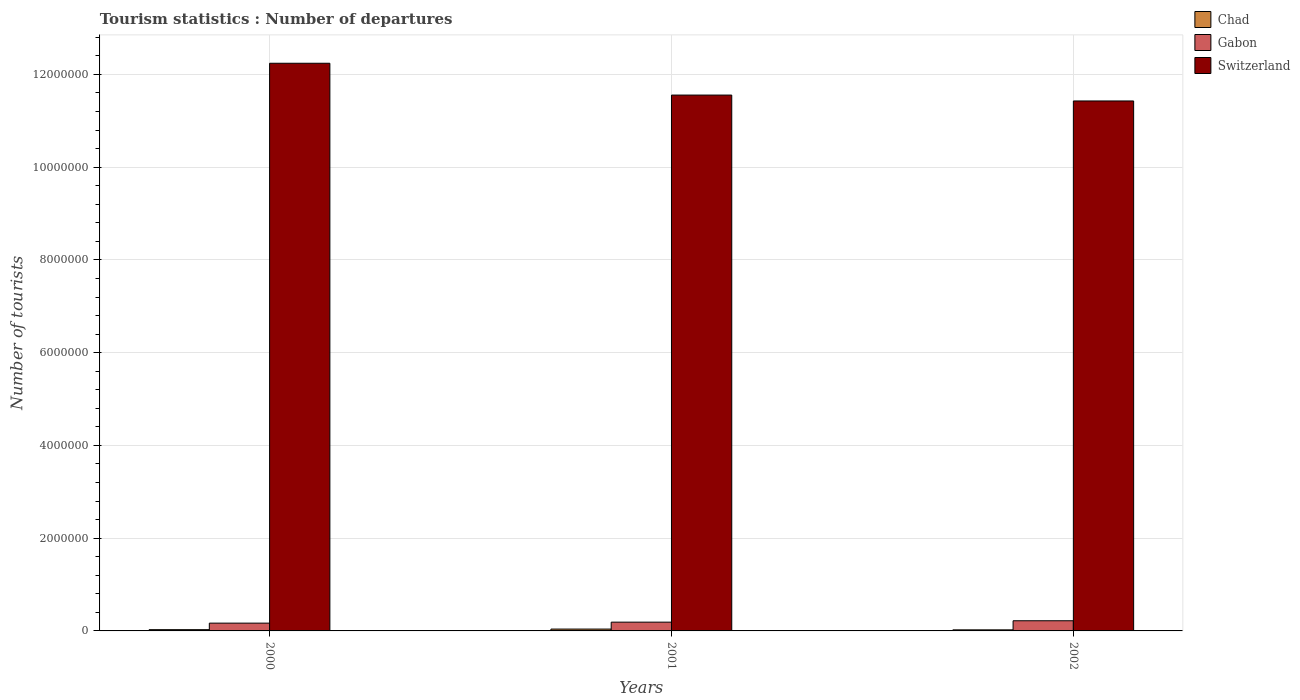How many different coloured bars are there?
Provide a succinct answer. 3. How many groups of bars are there?
Ensure brevity in your answer.  3. Are the number of bars on each tick of the X-axis equal?
Your answer should be very brief. Yes. How many bars are there on the 1st tick from the right?
Keep it short and to the point. 3. What is the label of the 3rd group of bars from the left?
Keep it short and to the point. 2002. In how many cases, is the number of bars for a given year not equal to the number of legend labels?
Your answer should be very brief. 0. What is the number of tourist departures in Gabon in 2002?
Provide a succinct answer. 2.19e+05. Across all years, what is the maximum number of tourist departures in Chad?
Your answer should be very brief. 4.00e+04. Across all years, what is the minimum number of tourist departures in Switzerland?
Your answer should be compact. 1.14e+07. In which year was the number of tourist departures in Switzerland minimum?
Your answer should be compact. 2002. What is the total number of tourist departures in Switzerland in the graph?
Your answer should be very brief. 3.52e+07. What is the difference between the number of tourist departures in Gabon in 2000 and that in 2002?
Offer a terse response. -5.10e+04. What is the difference between the number of tourist departures in Gabon in 2000 and the number of tourist departures in Chad in 2002?
Provide a succinct answer. 1.45e+05. What is the average number of tourist departures in Switzerland per year?
Give a very brief answer. 1.17e+07. In the year 2000, what is the difference between the number of tourist departures in Switzerland and number of tourist departures in Chad?
Make the answer very short. 1.22e+07. In how many years, is the number of tourist departures in Switzerland greater than 12400000?
Ensure brevity in your answer.  0. What is the ratio of the number of tourist departures in Gabon in 2000 to that in 2002?
Offer a terse response. 0.77. Is the difference between the number of tourist departures in Switzerland in 2000 and 2002 greater than the difference between the number of tourist departures in Chad in 2000 and 2002?
Provide a short and direct response. Yes. What is the difference between the highest and the second highest number of tourist departures in Chad?
Offer a very short reply. 1.30e+04. What is the difference between the highest and the lowest number of tourist departures in Gabon?
Your answer should be compact. 5.10e+04. In how many years, is the number of tourist departures in Gabon greater than the average number of tourist departures in Gabon taken over all years?
Keep it short and to the point. 1. Is the sum of the number of tourist departures in Gabon in 2001 and 2002 greater than the maximum number of tourist departures in Switzerland across all years?
Make the answer very short. No. What does the 2nd bar from the left in 2001 represents?
Ensure brevity in your answer.  Gabon. What does the 3rd bar from the right in 2000 represents?
Your answer should be compact. Chad. Is it the case that in every year, the sum of the number of tourist departures in Chad and number of tourist departures in Gabon is greater than the number of tourist departures in Switzerland?
Give a very brief answer. No. How many years are there in the graph?
Provide a short and direct response. 3. What is the difference between two consecutive major ticks on the Y-axis?
Your response must be concise. 2.00e+06. Are the values on the major ticks of Y-axis written in scientific E-notation?
Offer a terse response. No. Does the graph contain any zero values?
Keep it short and to the point. No. Does the graph contain grids?
Offer a very short reply. Yes. How are the legend labels stacked?
Make the answer very short. Vertical. What is the title of the graph?
Your response must be concise. Tourism statistics : Number of departures. What is the label or title of the X-axis?
Offer a terse response. Years. What is the label or title of the Y-axis?
Your response must be concise. Number of tourists. What is the Number of tourists in Chad in 2000?
Provide a short and direct response. 2.70e+04. What is the Number of tourists in Gabon in 2000?
Provide a succinct answer. 1.68e+05. What is the Number of tourists in Switzerland in 2000?
Ensure brevity in your answer.  1.22e+07. What is the Number of tourists in Gabon in 2001?
Your response must be concise. 1.89e+05. What is the Number of tourists of Switzerland in 2001?
Give a very brief answer. 1.16e+07. What is the Number of tourists of Chad in 2002?
Provide a succinct answer. 2.30e+04. What is the Number of tourists in Gabon in 2002?
Make the answer very short. 2.19e+05. What is the Number of tourists of Switzerland in 2002?
Offer a very short reply. 1.14e+07. Across all years, what is the maximum Number of tourists in Chad?
Ensure brevity in your answer.  4.00e+04. Across all years, what is the maximum Number of tourists in Gabon?
Offer a very short reply. 2.19e+05. Across all years, what is the maximum Number of tourists in Switzerland?
Provide a succinct answer. 1.22e+07. Across all years, what is the minimum Number of tourists of Chad?
Provide a succinct answer. 2.30e+04. Across all years, what is the minimum Number of tourists in Gabon?
Ensure brevity in your answer.  1.68e+05. Across all years, what is the minimum Number of tourists of Switzerland?
Your answer should be compact. 1.14e+07. What is the total Number of tourists of Gabon in the graph?
Provide a succinct answer. 5.76e+05. What is the total Number of tourists in Switzerland in the graph?
Your response must be concise. 3.52e+07. What is the difference between the Number of tourists in Chad in 2000 and that in 2001?
Make the answer very short. -1.30e+04. What is the difference between the Number of tourists of Gabon in 2000 and that in 2001?
Your answer should be very brief. -2.10e+04. What is the difference between the Number of tourists of Switzerland in 2000 and that in 2001?
Make the answer very short. 6.86e+05. What is the difference between the Number of tourists of Chad in 2000 and that in 2002?
Ensure brevity in your answer.  4000. What is the difference between the Number of tourists of Gabon in 2000 and that in 2002?
Provide a short and direct response. -5.10e+04. What is the difference between the Number of tourists in Switzerland in 2000 and that in 2002?
Make the answer very short. 8.13e+05. What is the difference between the Number of tourists of Chad in 2001 and that in 2002?
Your response must be concise. 1.70e+04. What is the difference between the Number of tourists of Gabon in 2001 and that in 2002?
Your answer should be compact. -3.00e+04. What is the difference between the Number of tourists in Switzerland in 2001 and that in 2002?
Make the answer very short. 1.27e+05. What is the difference between the Number of tourists of Chad in 2000 and the Number of tourists of Gabon in 2001?
Your answer should be compact. -1.62e+05. What is the difference between the Number of tourists in Chad in 2000 and the Number of tourists in Switzerland in 2001?
Make the answer very short. -1.15e+07. What is the difference between the Number of tourists in Gabon in 2000 and the Number of tourists in Switzerland in 2001?
Your answer should be compact. -1.14e+07. What is the difference between the Number of tourists in Chad in 2000 and the Number of tourists in Gabon in 2002?
Your answer should be compact. -1.92e+05. What is the difference between the Number of tourists in Chad in 2000 and the Number of tourists in Switzerland in 2002?
Your response must be concise. -1.14e+07. What is the difference between the Number of tourists in Gabon in 2000 and the Number of tourists in Switzerland in 2002?
Keep it short and to the point. -1.13e+07. What is the difference between the Number of tourists in Chad in 2001 and the Number of tourists in Gabon in 2002?
Provide a succinct answer. -1.79e+05. What is the difference between the Number of tourists in Chad in 2001 and the Number of tourists in Switzerland in 2002?
Your answer should be compact. -1.14e+07. What is the difference between the Number of tourists in Gabon in 2001 and the Number of tourists in Switzerland in 2002?
Give a very brief answer. -1.12e+07. What is the average Number of tourists in Chad per year?
Provide a short and direct response. 3.00e+04. What is the average Number of tourists in Gabon per year?
Offer a very short reply. 1.92e+05. What is the average Number of tourists in Switzerland per year?
Provide a succinct answer. 1.17e+07. In the year 2000, what is the difference between the Number of tourists in Chad and Number of tourists in Gabon?
Your answer should be compact. -1.41e+05. In the year 2000, what is the difference between the Number of tourists of Chad and Number of tourists of Switzerland?
Keep it short and to the point. -1.22e+07. In the year 2000, what is the difference between the Number of tourists in Gabon and Number of tourists in Switzerland?
Your answer should be very brief. -1.21e+07. In the year 2001, what is the difference between the Number of tourists in Chad and Number of tourists in Gabon?
Make the answer very short. -1.49e+05. In the year 2001, what is the difference between the Number of tourists in Chad and Number of tourists in Switzerland?
Give a very brief answer. -1.15e+07. In the year 2001, what is the difference between the Number of tourists of Gabon and Number of tourists of Switzerland?
Keep it short and to the point. -1.14e+07. In the year 2002, what is the difference between the Number of tourists of Chad and Number of tourists of Gabon?
Provide a short and direct response. -1.96e+05. In the year 2002, what is the difference between the Number of tourists in Chad and Number of tourists in Switzerland?
Your response must be concise. -1.14e+07. In the year 2002, what is the difference between the Number of tourists of Gabon and Number of tourists of Switzerland?
Your answer should be very brief. -1.12e+07. What is the ratio of the Number of tourists of Chad in 2000 to that in 2001?
Make the answer very short. 0.68. What is the ratio of the Number of tourists of Gabon in 2000 to that in 2001?
Provide a short and direct response. 0.89. What is the ratio of the Number of tourists of Switzerland in 2000 to that in 2001?
Your answer should be very brief. 1.06. What is the ratio of the Number of tourists in Chad in 2000 to that in 2002?
Provide a succinct answer. 1.17. What is the ratio of the Number of tourists of Gabon in 2000 to that in 2002?
Your answer should be compact. 0.77. What is the ratio of the Number of tourists of Switzerland in 2000 to that in 2002?
Provide a short and direct response. 1.07. What is the ratio of the Number of tourists in Chad in 2001 to that in 2002?
Provide a short and direct response. 1.74. What is the ratio of the Number of tourists in Gabon in 2001 to that in 2002?
Offer a terse response. 0.86. What is the ratio of the Number of tourists of Switzerland in 2001 to that in 2002?
Keep it short and to the point. 1.01. What is the difference between the highest and the second highest Number of tourists in Chad?
Your response must be concise. 1.30e+04. What is the difference between the highest and the second highest Number of tourists in Gabon?
Ensure brevity in your answer.  3.00e+04. What is the difference between the highest and the second highest Number of tourists of Switzerland?
Provide a short and direct response. 6.86e+05. What is the difference between the highest and the lowest Number of tourists of Chad?
Your answer should be compact. 1.70e+04. What is the difference between the highest and the lowest Number of tourists of Gabon?
Make the answer very short. 5.10e+04. What is the difference between the highest and the lowest Number of tourists in Switzerland?
Offer a terse response. 8.13e+05. 